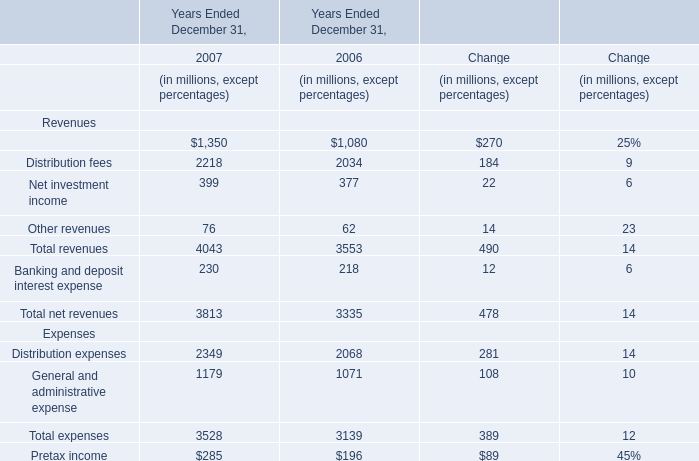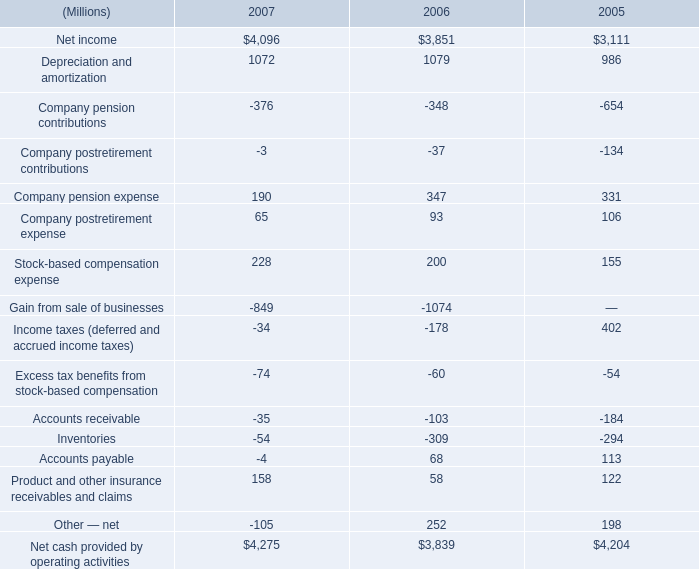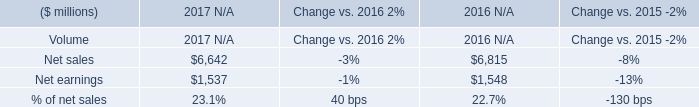What is the average amount of Net earnings of 2017 N/A, and Net income of 2006 ? 
Computations: ((1537.0 + 3851.0) / 2)
Answer: 2694.0. what was the percentage change in the net income 
Computations: ((4096 - 3851) / 3851)
Answer: 0.06362. what's the total amount of Depreciation and amortization of 2007, and Net earnings of 2017 N/A ? 
Computations: (1072.0 + 1537.0)
Answer: 2609.0. 